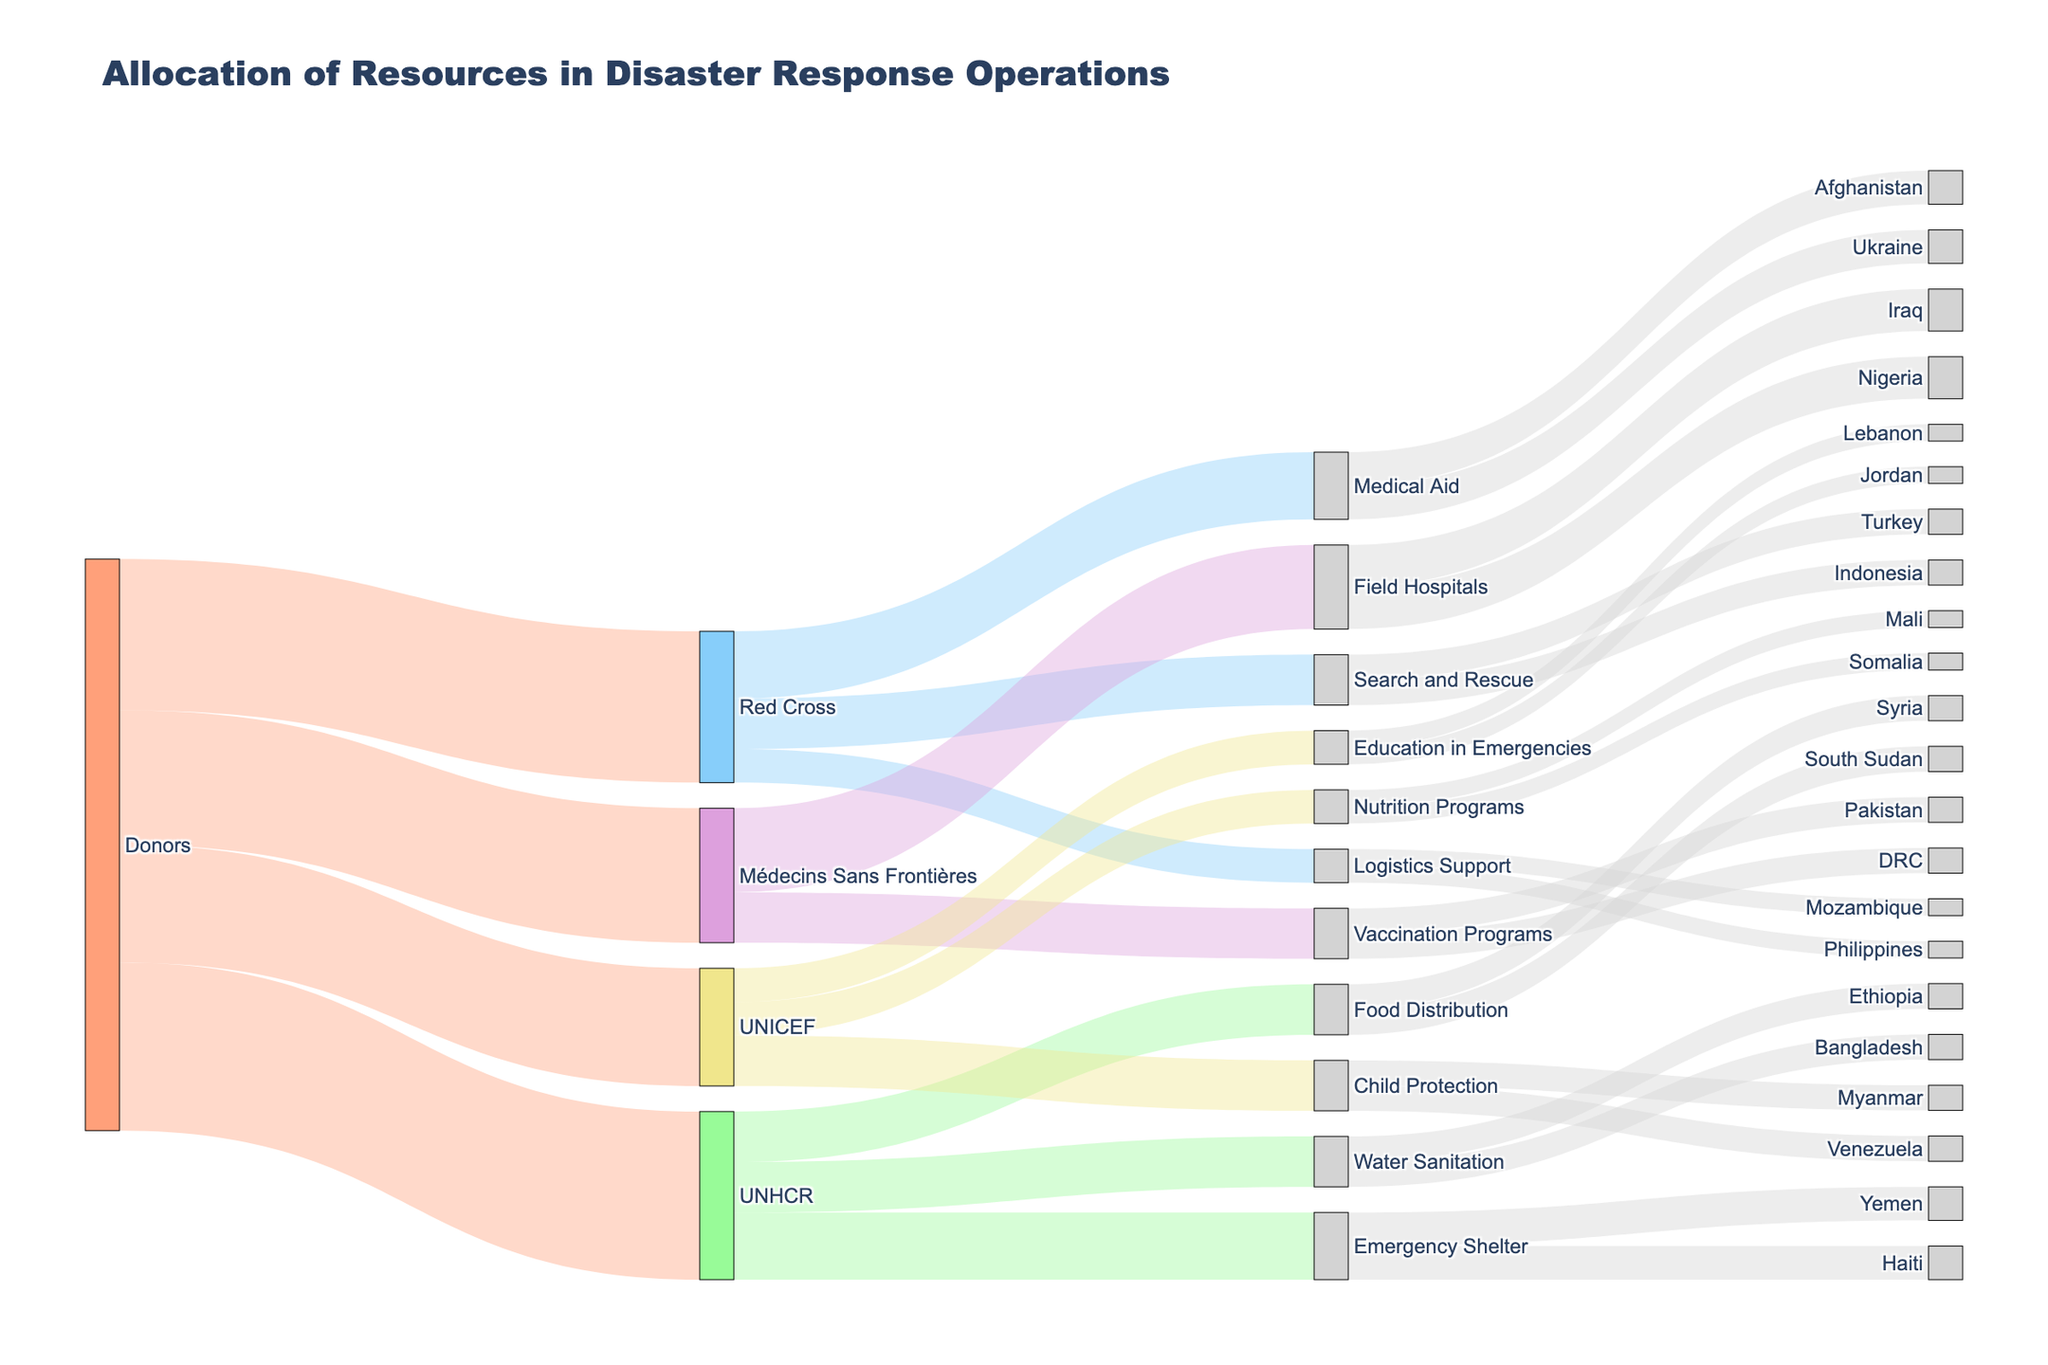How many donors contribute to Médecins Sans Frontières? By looking at the Sankey Diagram, we can see that the source labeled "Donors" connects to Médecins Sans Frontières directly. Since there is only one source node for Médecins Sans Frontières, it indicates that there is exactly one group of donors.
Answer: 1 Which organization receives the most resources from donors? To determine which organization receives the most resources, we need to compare the values of the links between donors and each organization (UNHCR, Red Cross, Médecins Sans Frontières, and UNICEF). Médecins Sans Frontières receives 400 units, UNHCR receives 500 units, Red Cross receives 450 units, and UNICEF receives 350 units. 500 is the highest value.
Answer: UNHCR How many units of resources go to Yemen for Emergency Shelters? By checking the flow from the "Emergency Shelter" node to the affected areas, it is seen that a total of 100 units flow to Yemen.
Answer: 100 Which two programs under Médecins Sans Frontières receive resources and how much is allocated to each? Médecins Sans Frontières allocates resources to "Field Hospitals" and "Vaccination Programs", with 250 units going to Field Hospitals and 150 units going to Vaccination Programs.
Answer: Field Hospitals: 250, Vaccination Programs: 150 Compare the resources allocated for Child Protection by UNICEF in Myanmar and Venezuela. Are they equal? By inspecting the Sankey Diagram, Child Protection is connected to both Myanmar and Venezuela, each with a flow of 75 units.
Answer: Yes How many total units does UNICEF allocate to all its programs? UNICEF allocates resources to several programs - Child Protection (150), Education in Emergencies (100), and Nutrition Programs (100). Summing these values gives 150 + 100 + 100 = 350 units.
Answer: 350 Which affected area receives the highest amount of resources for Food Distribution, and how much? From the Food Distribution node, resources are distributed to South Sudan and Syria. Both receive equal amounts, 75 units each.
Answer: South Sudan and Syria, 75 each What's the total amount of resources allocated to Ethiopia across all programs? The only flow to Ethiopia in the Sankey Diagram comes from the "Water Sanitation" node, allocating 75 units in total.
Answer: 75 What proportion of the total resources from Donors goes to each organization? The total resources from Donors are: UNHCR (500), Red Cross (450), Médecins Sans Frontières (400), UNICEF (350), making a total of 1700 units. Thus, the proportions are: UNHCR - 500/1700 = 29.4%, Red Cross - 450/1700 = 26.5%, Médecins Sans Frontières - 400/1700 = 23.5%, UNICEF - 350/1700 = 20.6%.
Answer: UNHCR: 29.4%, Red Cross: 26.5%, Médecins Sans Frontières: 23.5%, UNICEF: 20.6% Which organization supports Nutrition Programs, and how much is allocated? UNICEF supports Nutrition Programs. They allocate 100 units to it.
Answer: UNICEF, 100 